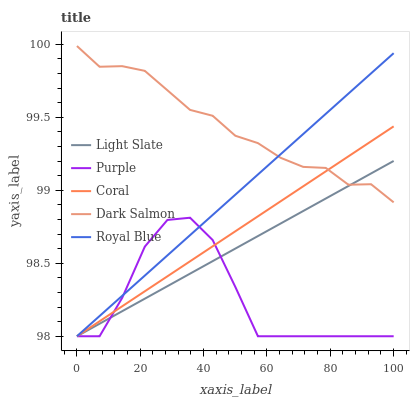Does Coral have the minimum area under the curve?
Answer yes or no. No. Does Coral have the maximum area under the curve?
Answer yes or no. No. Is Coral the smoothest?
Answer yes or no. No. Is Coral the roughest?
Answer yes or no. No. Does Dark Salmon have the lowest value?
Answer yes or no. No. Does Coral have the highest value?
Answer yes or no. No. Is Purple less than Dark Salmon?
Answer yes or no. Yes. Is Dark Salmon greater than Purple?
Answer yes or no. Yes. Does Purple intersect Dark Salmon?
Answer yes or no. No. 